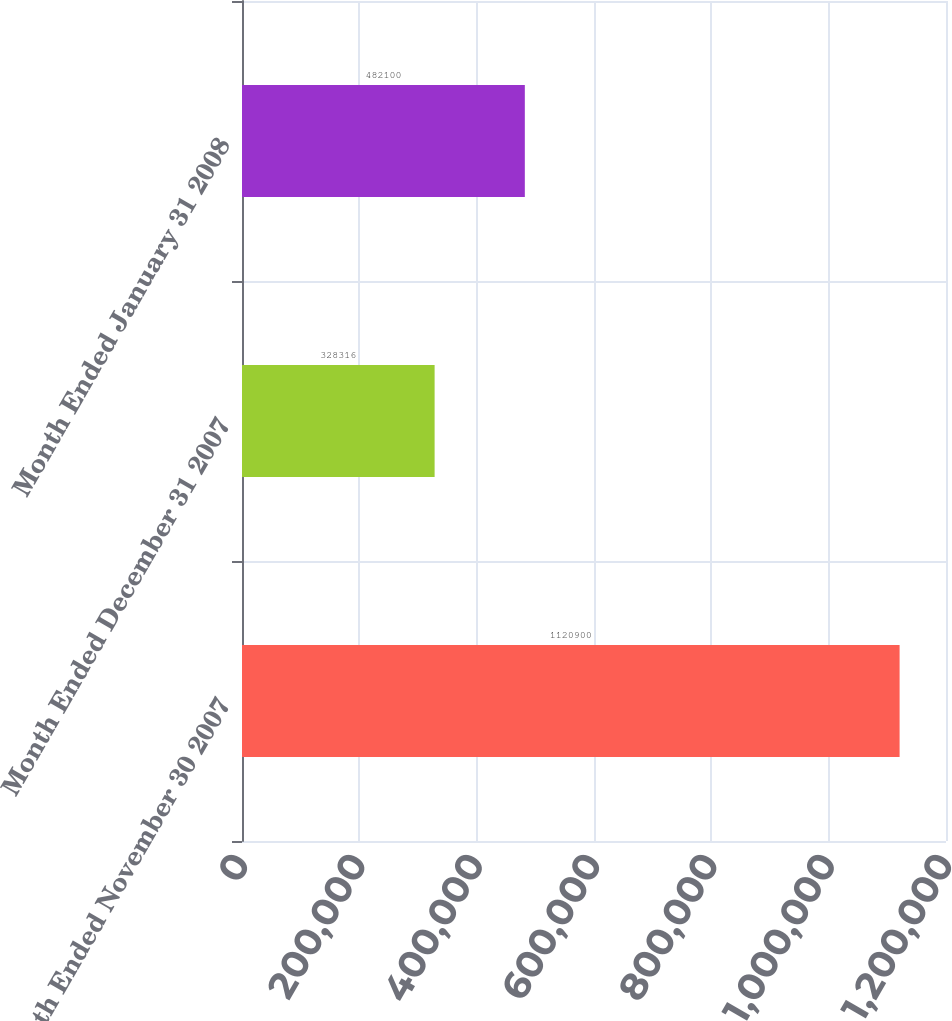<chart> <loc_0><loc_0><loc_500><loc_500><bar_chart><fcel>Month Ended November 30 2007<fcel>Month Ended December 31 2007<fcel>Month Ended January 31 2008<nl><fcel>1.1209e+06<fcel>328316<fcel>482100<nl></chart> 